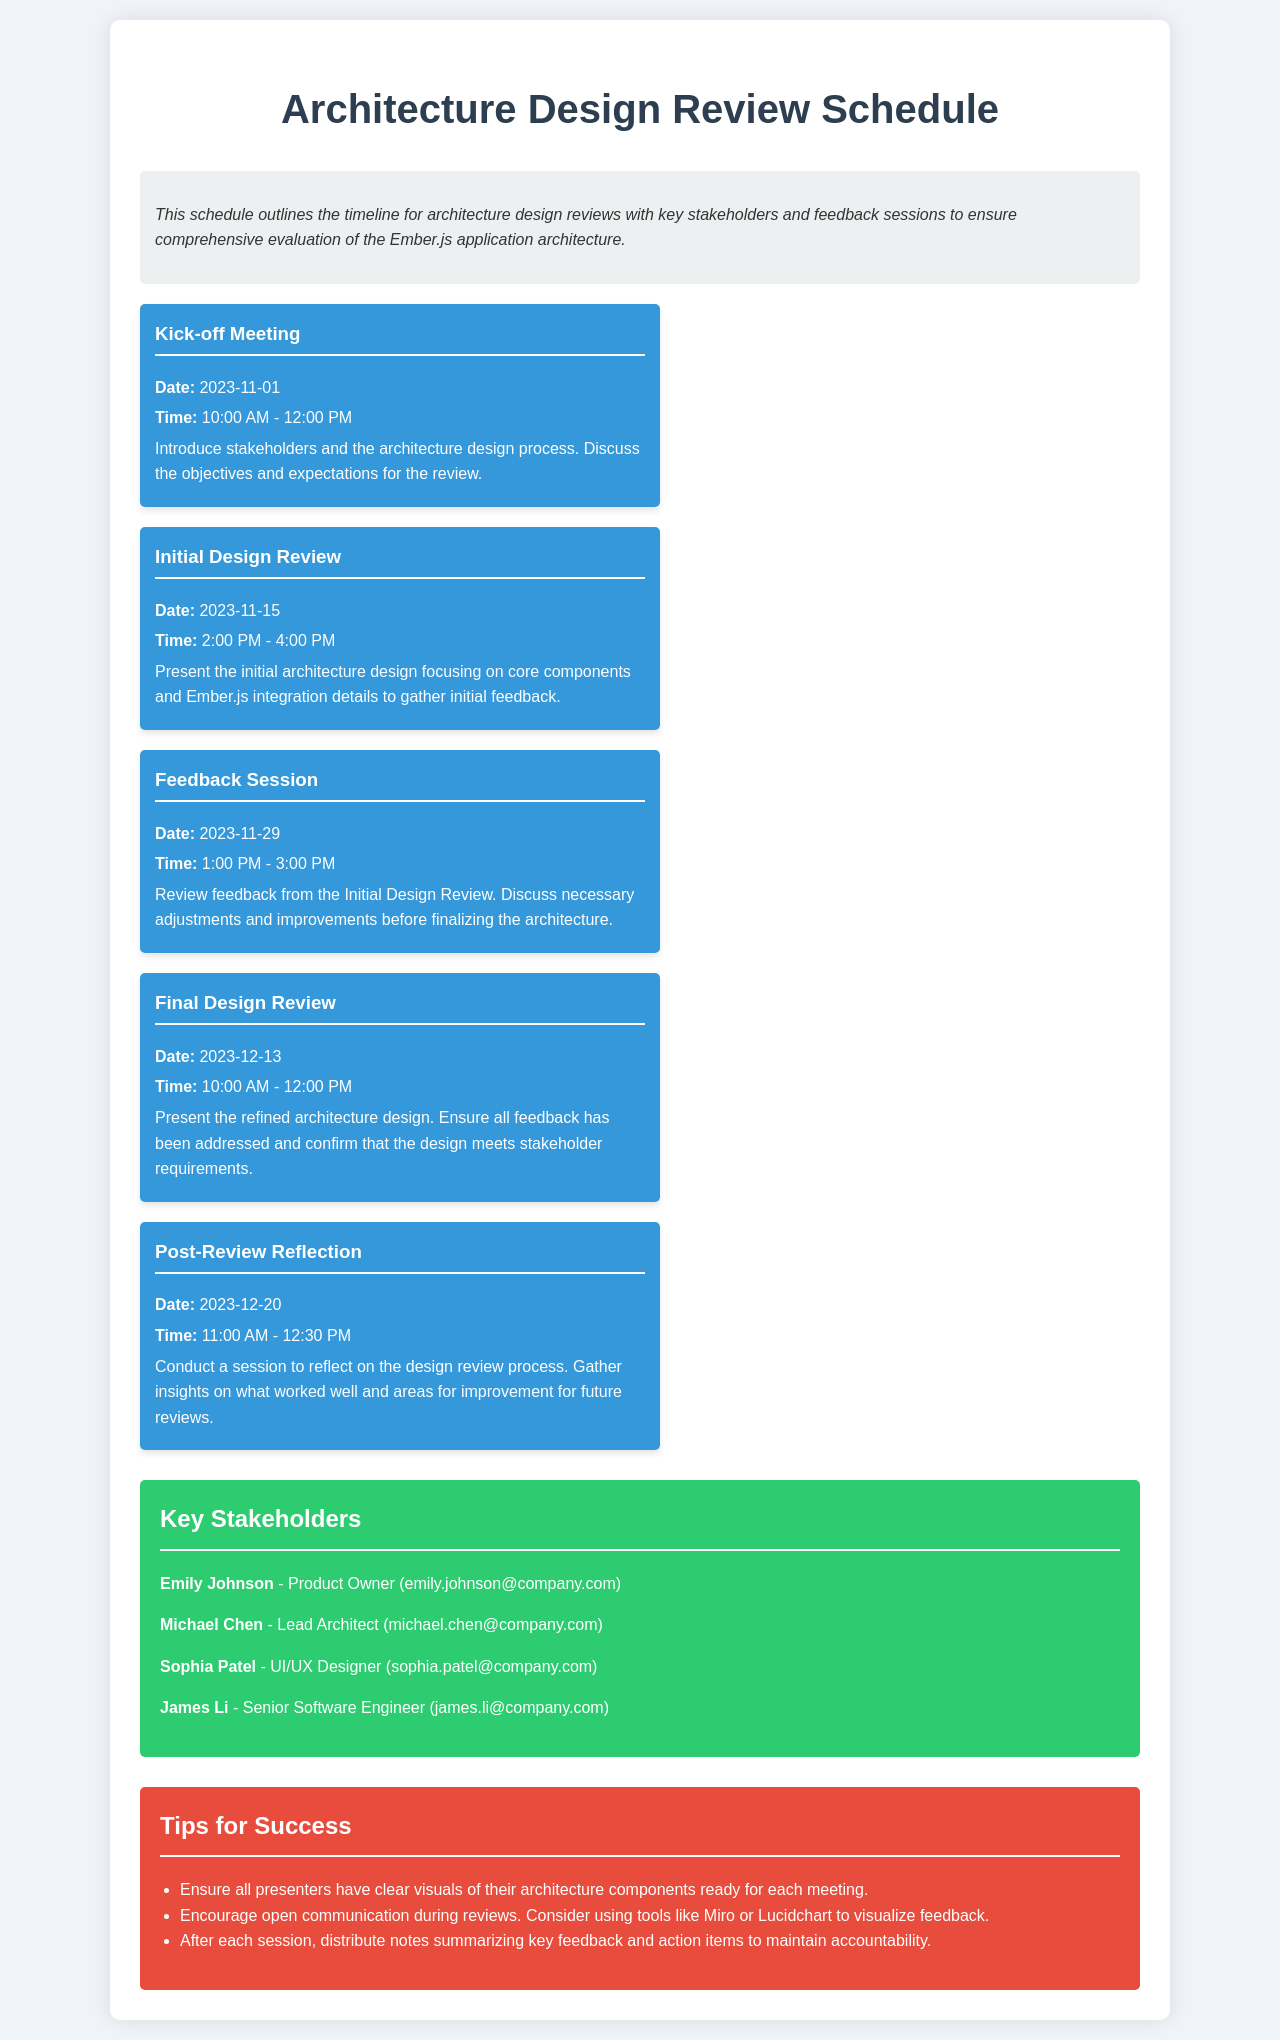What is the date of the Kick-off Meeting? The date is listed under the Kick-off Meeting event in the schedule.
Answer: 2023-11-01 What time is the Final Design Review scheduled for? The time is specified in the description of the Final Design Review event.
Answer: 10:00 AM - 12:00 PM Who is the Product Owner listed in the Key Stakeholders section? The Product Owner's name is directly provided in the Key Stakeholders section.
Answer: Emily Johnson How many events are scheduled before the Feedback Session? The count is determined by reviewing the events listed in the schedule that occur before the Feedback Session.
Answer: 2 What is one of the Tips for Success mentioned in the schedule? A few tips are listed, and any of them can be an answer.
Answer: Ensure all presenters have clear visuals of their architecture components ready for each meeting What date does the Post-Review Reflection take place? The date is found in the event description for the Post-Review Reflection.
Answer: 2023-12-20 Who is the Lead Architect among the Key Stakeholders? The position and name are provided in the Key Stakeholders section.
Answer: Michael Chen What is the primary objective of the Kick-off Meeting? The objective is described in the event details of the Kick-off Meeting.
Answer: Introduce stakeholders and the architecture design process 